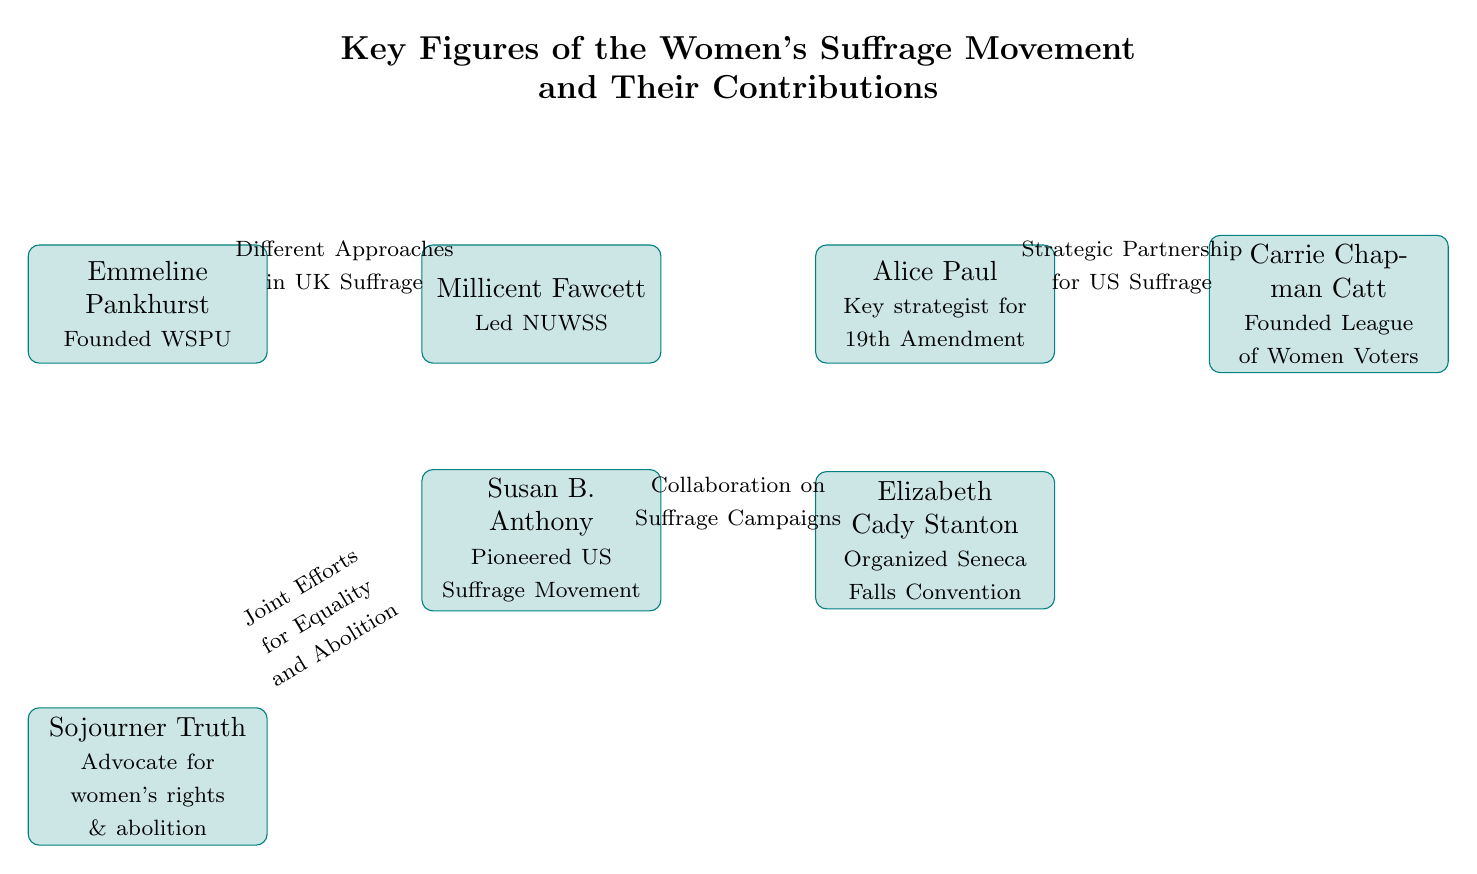What is the title of the diagram? The title node in the diagram, located at the top, clearly states "Key Figures of the Women's Suffrage Movement and Their Contributions." This node summarizes the overall theme of the diagram.
Answer: Key Figures of the Women's Suffrage Movement and Their Contributions How many key figures are depicted in the diagram? By counting each of the "person" nodes present in the diagram, there are a total of seven nodes representing significant figures in the women's suffrage movement.
Answer: 7 Who is associated with founding the WSPU? The node for Emmeline Pankhurst indicates her contribution. The information in this node specifically states that she "Founded WSPU," which is the primary detail for this question.
Answer: Emmeline Pankhurst What contribution is Susan B. Anthony known for? The node for Susan B. Anthony specifically states she "Pioneered US Suffrage Movement." This information succinctly defines her role within the context of women's suffrage in the United States.
Answer: Pioneered US Suffrage Movement Which figures are connected by the arrow labeled "Different Approaches in UK Suffrage"? The arrow connects Emmeline Pankhurst and Millicent Fawcett, and the corresponding label describes their relationship regarding different strategies in the UK suffrage movement.
Answer: Emmeline Pankhurst and Millicent Fawcett Who did Sojourner Truth collaborate with? The arrow from Sojourner Truth points to Susan B. Anthony, with the label indicating their "Joint Efforts for Equality and Abolition." This implies that they worked together on issues of women's rights and abolition.
Answer: Susan B. Anthony Which two figures are connected by the strategic partnership for US suffrage? The arrow labeled "Strategic Partnership for US Suffrage" connects Alice Paul and Carrie Chapman Catt, indicating their collaboration in the context of the suffrage movement in the United States.
Answer: Alice Paul and Carrie Chapman Catt What role did Millicent Fawcett play in the women's suffrage movement? The contribution mentioned in her node is that she "Led NUWSS," identifying her leadership role in the National Union of Women's Suffrage Societies. This information provides insight into her significance within the movement.
Answer: Led NUWSS 